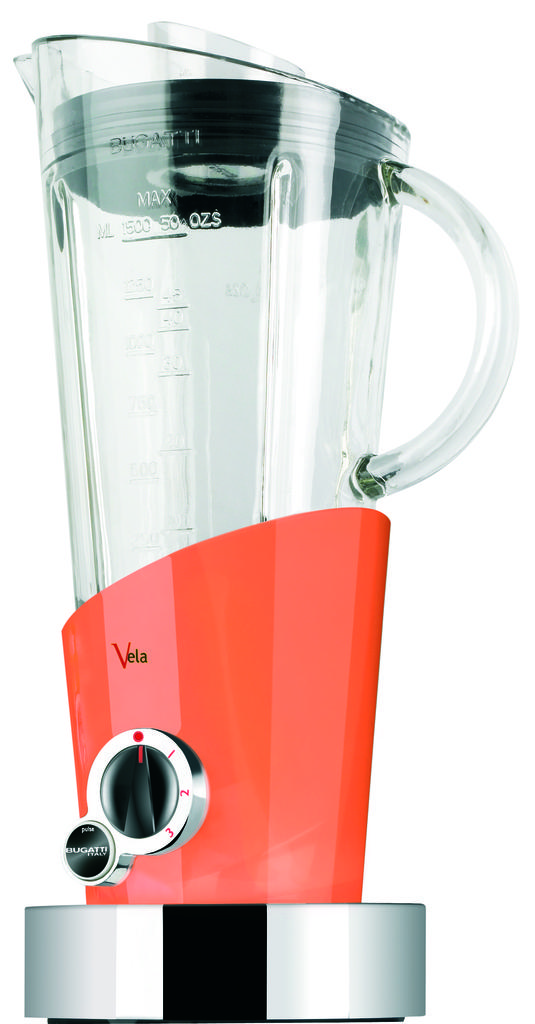What is the red writing on the bottom?
Your answer should be very brief. Vela. 